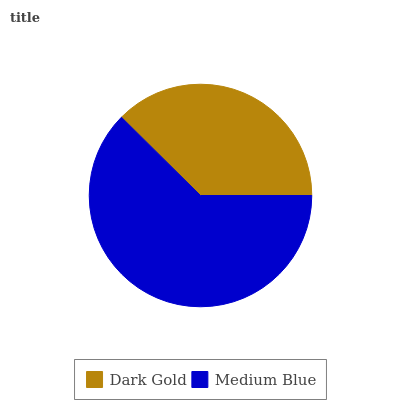Is Dark Gold the minimum?
Answer yes or no. Yes. Is Medium Blue the maximum?
Answer yes or no. Yes. Is Medium Blue the minimum?
Answer yes or no. No. Is Medium Blue greater than Dark Gold?
Answer yes or no. Yes. Is Dark Gold less than Medium Blue?
Answer yes or no. Yes. Is Dark Gold greater than Medium Blue?
Answer yes or no. No. Is Medium Blue less than Dark Gold?
Answer yes or no. No. Is Medium Blue the high median?
Answer yes or no. Yes. Is Dark Gold the low median?
Answer yes or no. Yes. Is Dark Gold the high median?
Answer yes or no. No. Is Medium Blue the low median?
Answer yes or no. No. 